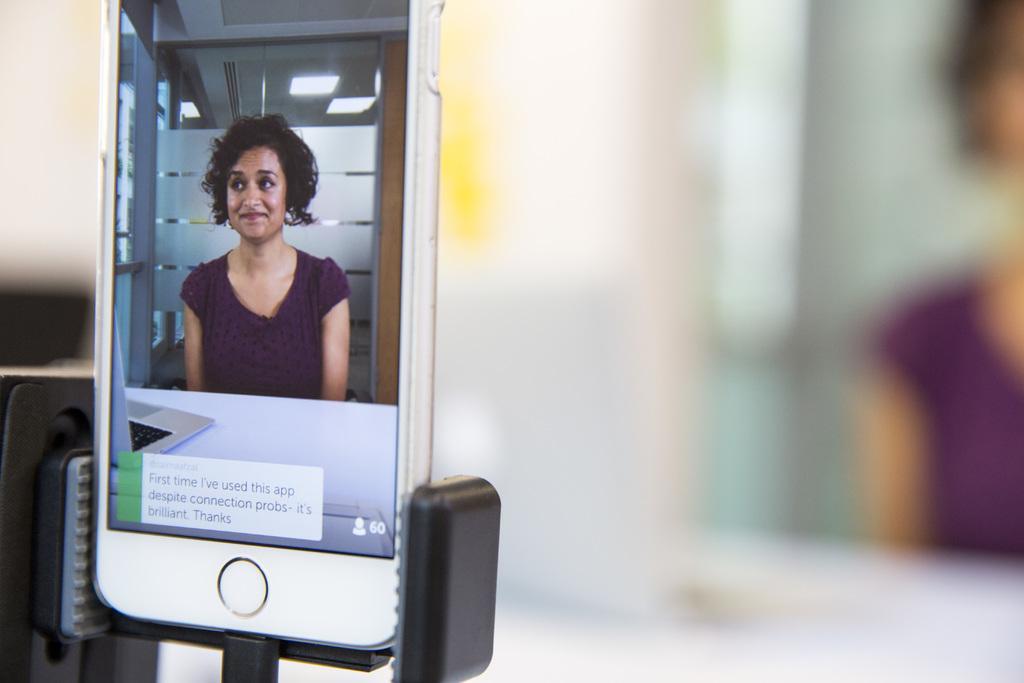In one or two sentences, can you explain what this image depicts? We can see mobile,screen and stand,in this screen we can see a woman and smiling,in front of her we can see laptop on the table,behind her we can see glass and lights and we can see some text. In the background it is blur. 